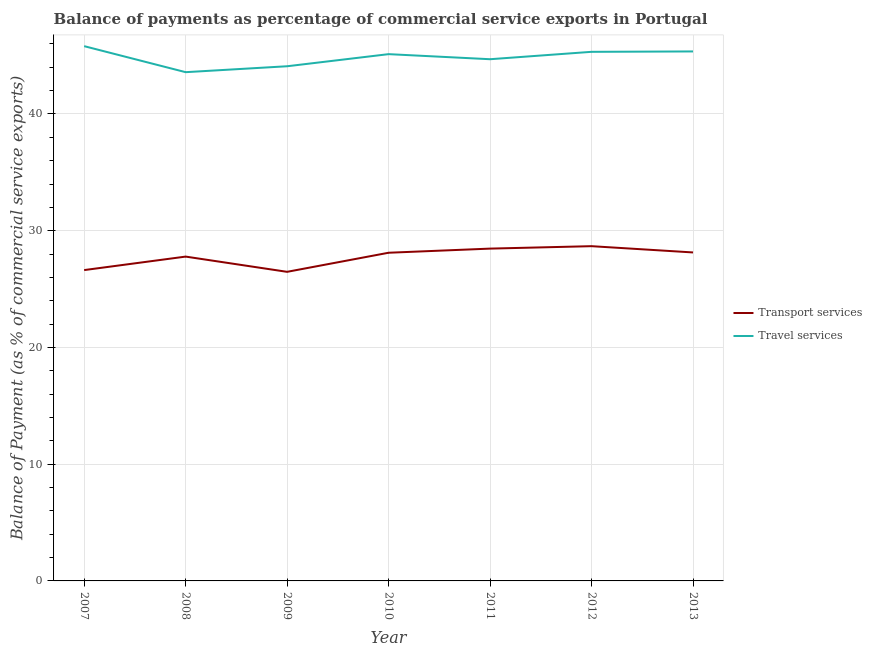How many different coloured lines are there?
Your response must be concise. 2. Does the line corresponding to balance of payments of travel services intersect with the line corresponding to balance of payments of transport services?
Keep it short and to the point. No. Is the number of lines equal to the number of legend labels?
Your answer should be very brief. Yes. What is the balance of payments of travel services in 2009?
Offer a terse response. 44.09. Across all years, what is the maximum balance of payments of transport services?
Make the answer very short. 28.68. Across all years, what is the minimum balance of payments of transport services?
Ensure brevity in your answer.  26.48. In which year was the balance of payments of travel services minimum?
Your response must be concise. 2008. What is the total balance of payments of transport services in the graph?
Provide a short and direct response. 194.28. What is the difference between the balance of payments of transport services in 2010 and that in 2012?
Provide a succinct answer. -0.56. What is the difference between the balance of payments of travel services in 2013 and the balance of payments of transport services in 2010?
Provide a short and direct response. 17.25. What is the average balance of payments of travel services per year?
Provide a short and direct response. 44.85. In the year 2007, what is the difference between the balance of payments of transport services and balance of payments of travel services?
Keep it short and to the point. -19.18. What is the ratio of the balance of payments of travel services in 2007 to that in 2012?
Give a very brief answer. 1.01. Is the difference between the balance of payments of transport services in 2008 and 2010 greater than the difference between the balance of payments of travel services in 2008 and 2010?
Keep it short and to the point. Yes. What is the difference between the highest and the second highest balance of payments of transport services?
Provide a succinct answer. 0.21. What is the difference between the highest and the lowest balance of payments of travel services?
Your answer should be very brief. 2.23. Is the sum of the balance of payments of travel services in 2011 and 2012 greater than the maximum balance of payments of transport services across all years?
Provide a short and direct response. Yes. Is the balance of payments of transport services strictly greater than the balance of payments of travel services over the years?
Your answer should be very brief. No. How many legend labels are there?
Your answer should be very brief. 2. What is the title of the graph?
Make the answer very short. Balance of payments as percentage of commercial service exports in Portugal. What is the label or title of the Y-axis?
Your answer should be very brief. Balance of Payment (as % of commercial service exports). What is the Balance of Payment (as % of commercial service exports) of Transport services in 2007?
Offer a terse response. 26.63. What is the Balance of Payment (as % of commercial service exports) of Travel services in 2007?
Provide a short and direct response. 45.81. What is the Balance of Payment (as % of commercial service exports) of Transport services in 2008?
Ensure brevity in your answer.  27.78. What is the Balance of Payment (as % of commercial service exports) in Travel services in 2008?
Your answer should be very brief. 43.58. What is the Balance of Payment (as % of commercial service exports) of Transport services in 2009?
Your response must be concise. 26.48. What is the Balance of Payment (as % of commercial service exports) of Travel services in 2009?
Your answer should be very brief. 44.09. What is the Balance of Payment (as % of commercial service exports) of Transport services in 2010?
Offer a terse response. 28.11. What is the Balance of Payment (as % of commercial service exports) in Travel services in 2010?
Provide a succinct answer. 45.13. What is the Balance of Payment (as % of commercial service exports) in Transport services in 2011?
Make the answer very short. 28.47. What is the Balance of Payment (as % of commercial service exports) of Travel services in 2011?
Your response must be concise. 44.69. What is the Balance of Payment (as % of commercial service exports) of Transport services in 2012?
Your answer should be compact. 28.68. What is the Balance of Payment (as % of commercial service exports) of Travel services in 2012?
Your answer should be very brief. 45.33. What is the Balance of Payment (as % of commercial service exports) in Transport services in 2013?
Offer a terse response. 28.14. What is the Balance of Payment (as % of commercial service exports) of Travel services in 2013?
Ensure brevity in your answer.  45.36. Across all years, what is the maximum Balance of Payment (as % of commercial service exports) in Transport services?
Your response must be concise. 28.68. Across all years, what is the maximum Balance of Payment (as % of commercial service exports) of Travel services?
Your answer should be compact. 45.81. Across all years, what is the minimum Balance of Payment (as % of commercial service exports) of Transport services?
Your answer should be very brief. 26.48. Across all years, what is the minimum Balance of Payment (as % of commercial service exports) in Travel services?
Make the answer very short. 43.58. What is the total Balance of Payment (as % of commercial service exports) in Transport services in the graph?
Provide a succinct answer. 194.28. What is the total Balance of Payment (as % of commercial service exports) in Travel services in the graph?
Your answer should be very brief. 313.98. What is the difference between the Balance of Payment (as % of commercial service exports) of Transport services in 2007 and that in 2008?
Your answer should be very brief. -1.16. What is the difference between the Balance of Payment (as % of commercial service exports) in Travel services in 2007 and that in 2008?
Give a very brief answer. 2.23. What is the difference between the Balance of Payment (as % of commercial service exports) in Transport services in 2007 and that in 2009?
Ensure brevity in your answer.  0.15. What is the difference between the Balance of Payment (as % of commercial service exports) in Travel services in 2007 and that in 2009?
Your answer should be compact. 1.72. What is the difference between the Balance of Payment (as % of commercial service exports) in Transport services in 2007 and that in 2010?
Offer a terse response. -1.49. What is the difference between the Balance of Payment (as % of commercial service exports) in Travel services in 2007 and that in 2010?
Provide a succinct answer. 0.68. What is the difference between the Balance of Payment (as % of commercial service exports) of Transport services in 2007 and that in 2011?
Your answer should be compact. -1.84. What is the difference between the Balance of Payment (as % of commercial service exports) in Travel services in 2007 and that in 2011?
Offer a very short reply. 1.12. What is the difference between the Balance of Payment (as % of commercial service exports) of Transport services in 2007 and that in 2012?
Provide a succinct answer. -2.05. What is the difference between the Balance of Payment (as % of commercial service exports) in Travel services in 2007 and that in 2012?
Provide a succinct answer. 0.49. What is the difference between the Balance of Payment (as % of commercial service exports) of Transport services in 2007 and that in 2013?
Your answer should be very brief. -1.51. What is the difference between the Balance of Payment (as % of commercial service exports) of Travel services in 2007 and that in 2013?
Give a very brief answer. 0.45. What is the difference between the Balance of Payment (as % of commercial service exports) in Transport services in 2008 and that in 2009?
Ensure brevity in your answer.  1.31. What is the difference between the Balance of Payment (as % of commercial service exports) of Travel services in 2008 and that in 2009?
Your answer should be compact. -0.51. What is the difference between the Balance of Payment (as % of commercial service exports) of Transport services in 2008 and that in 2010?
Make the answer very short. -0.33. What is the difference between the Balance of Payment (as % of commercial service exports) in Travel services in 2008 and that in 2010?
Provide a short and direct response. -1.54. What is the difference between the Balance of Payment (as % of commercial service exports) of Transport services in 2008 and that in 2011?
Your response must be concise. -0.68. What is the difference between the Balance of Payment (as % of commercial service exports) of Travel services in 2008 and that in 2011?
Ensure brevity in your answer.  -1.11. What is the difference between the Balance of Payment (as % of commercial service exports) in Transport services in 2008 and that in 2012?
Your response must be concise. -0.89. What is the difference between the Balance of Payment (as % of commercial service exports) in Travel services in 2008 and that in 2012?
Make the answer very short. -1.74. What is the difference between the Balance of Payment (as % of commercial service exports) of Transport services in 2008 and that in 2013?
Your answer should be compact. -0.36. What is the difference between the Balance of Payment (as % of commercial service exports) of Travel services in 2008 and that in 2013?
Keep it short and to the point. -1.78. What is the difference between the Balance of Payment (as % of commercial service exports) of Transport services in 2009 and that in 2010?
Offer a very short reply. -1.64. What is the difference between the Balance of Payment (as % of commercial service exports) of Travel services in 2009 and that in 2010?
Your answer should be very brief. -1.04. What is the difference between the Balance of Payment (as % of commercial service exports) in Transport services in 2009 and that in 2011?
Offer a very short reply. -1.99. What is the difference between the Balance of Payment (as % of commercial service exports) of Travel services in 2009 and that in 2011?
Offer a terse response. -0.6. What is the difference between the Balance of Payment (as % of commercial service exports) in Transport services in 2009 and that in 2012?
Provide a short and direct response. -2.2. What is the difference between the Balance of Payment (as % of commercial service exports) in Travel services in 2009 and that in 2012?
Provide a short and direct response. -1.24. What is the difference between the Balance of Payment (as % of commercial service exports) of Transport services in 2009 and that in 2013?
Make the answer very short. -1.66. What is the difference between the Balance of Payment (as % of commercial service exports) of Travel services in 2009 and that in 2013?
Ensure brevity in your answer.  -1.27. What is the difference between the Balance of Payment (as % of commercial service exports) of Transport services in 2010 and that in 2011?
Your answer should be compact. -0.35. What is the difference between the Balance of Payment (as % of commercial service exports) of Travel services in 2010 and that in 2011?
Your answer should be very brief. 0.43. What is the difference between the Balance of Payment (as % of commercial service exports) of Transport services in 2010 and that in 2012?
Provide a short and direct response. -0.56. What is the difference between the Balance of Payment (as % of commercial service exports) of Travel services in 2010 and that in 2012?
Provide a short and direct response. -0.2. What is the difference between the Balance of Payment (as % of commercial service exports) in Transport services in 2010 and that in 2013?
Offer a very short reply. -0.03. What is the difference between the Balance of Payment (as % of commercial service exports) of Travel services in 2010 and that in 2013?
Offer a very short reply. -0.23. What is the difference between the Balance of Payment (as % of commercial service exports) of Transport services in 2011 and that in 2012?
Give a very brief answer. -0.21. What is the difference between the Balance of Payment (as % of commercial service exports) of Travel services in 2011 and that in 2012?
Offer a very short reply. -0.63. What is the difference between the Balance of Payment (as % of commercial service exports) in Transport services in 2011 and that in 2013?
Your response must be concise. 0.33. What is the difference between the Balance of Payment (as % of commercial service exports) of Travel services in 2011 and that in 2013?
Your response must be concise. -0.67. What is the difference between the Balance of Payment (as % of commercial service exports) of Transport services in 2012 and that in 2013?
Give a very brief answer. 0.54. What is the difference between the Balance of Payment (as % of commercial service exports) in Travel services in 2012 and that in 2013?
Offer a very short reply. -0.03. What is the difference between the Balance of Payment (as % of commercial service exports) in Transport services in 2007 and the Balance of Payment (as % of commercial service exports) in Travel services in 2008?
Your answer should be very brief. -16.95. What is the difference between the Balance of Payment (as % of commercial service exports) of Transport services in 2007 and the Balance of Payment (as % of commercial service exports) of Travel services in 2009?
Provide a succinct answer. -17.46. What is the difference between the Balance of Payment (as % of commercial service exports) in Transport services in 2007 and the Balance of Payment (as % of commercial service exports) in Travel services in 2010?
Provide a succinct answer. -18.5. What is the difference between the Balance of Payment (as % of commercial service exports) in Transport services in 2007 and the Balance of Payment (as % of commercial service exports) in Travel services in 2011?
Your answer should be very brief. -18.06. What is the difference between the Balance of Payment (as % of commercial service exports) of Transport services in 2007 and the Balance of Payment (as % of commercial service exports) of Travel services in 2012?
Give a very brief answer. -18.7. What is the difference between the Balance of Payment (as % of commercial service exports) of Transport services in 2007 and the Balance of Payment (as % of commercial service exports) of Travel services in 2013?
Give a very brief answer. -18.73. What is the difference between the Balance of Payment (as % of commercial service exports) of Transport services in 2008 and the Balance of Payment (as % of commercial service exports) of Travel services in 2009?
Give a very brief answer. -16.31. What is the difference between the Balance of Payment (as % of commercial service exports) in Transport services in 2008 and the Balance of Payment (as % of commercial service exports) in Travel services in 2010?
Your response must be concise. -17.34. What is the difference between the Balance of Payment (as % of commercial service exports) of Transport services in 2008 and the Balance of Payment (as % of commercial service exports) of Travel services in 2011?
Your response must be concise. -16.91. What is the difference between the Balance of Payment (as % of commercial service exports) in Transport services in 2008 and the Balance of Payment (as % of commercial service exports) in Travel services in 2012?
Provide a short and direct response. -17.54. What is the difference between the Balance of Payment (as % of commercial service exports) in Transport services in 2008 and the Balance of Payment (as % of commercial service exports) in Travel services in 2013?
Keep it short and to the point. -17.58. What is the difference between the Balance of Payment (as % of commercial service exports) in Transport services in 2009 and the Balance of Payment (as % of commercial service exports) in Travel services in 2010?
Ensure brevity in your answer.  -18.65. What is the difference between the Balance of Payment (as % of commercial service exports) in Transport services in 2009 and the Balance of Payment (as % of commercial service exports) in Travel services in 2011?
Your answer should be very brief. -18.21. What is the difference between the Balance of Payment (as % of commercial service exports) of Transport services in 2009 and the Balance of Payment (as % of commercial service exports) of Travel services in 2012?
Your response must be concise. -18.85. What is the difference between the Balance of Payment (as % of commercial service exports) of Transport services in 2009 and the Balance of Payment (as % of commercial service exports) of Travel services in 2013?
Your answer should be compact. -18.88. What is the difference between the Balance of Payment (as % of commercial service exports) in Transport services in 2010 and the Balance of Payment (as % of commercial service exports) in Travel services in 2011?
Provide a succinct answer. -16.58. What is the difference between the Balance of Payment (as % of commercial service exports) in Transport services in 2010 and the Balance of Payment (as % of commercial service exports) in Travel services in 2012?
Your response must be concise. -17.21. What is the difference between the Balance of Payment (as % of commercial service exports) in Transport services in 2010 and the Balance of Payment (as % of commercial service exports) in Travel services in 2013?
Your answer should be compact. -17.25. What is the difference between the Balance of Payment (as % of commercial service exports) in Transport services in 2011 and the Balance of Payment (as % of commercial service exports) in Travel services in 2012?
Give a very brief answer. -16.86. What is the difference between the Balance of Payment (as % of commercial service exports) in Transport services in 2011 and the Balance of Payment (as % of commercial service exports) in Travel services in 2013?
Provide a succinct answer. -16.89. What is the difference between the Balance of Payment (as % of commercial service exports) in Transport services in 2012 and the Balance of Payment (as % of commercial service exports) in Travel services in 2013?
Make the answer very short. -16.68. What is the average Balance of Payment (as % of commercial service exports) of Transport services per year?
Offer a very short reply. 27.75. What is the average Balance of Payment (as % of commercial service exports) in Travel services per year?
Make the answer very short. 44.85. In the year 2007, what is the difference between the Balance of Payment (as % of commercial service exports) of Transport services and Balance of Payment (as % of commercial service exports) of Travel services?
Give a very brief answer. -19.18. In the year 2008, what is the difference between the Balance of Payment (as % of commercial service exports) in Transport services and Balance of Payment (as % of commercial service exports) in Travel services?
Your answer should be very brief. -15.8. In the year 2009, what is the difference between the Balance of Payment (as % of commercial service exports) of Transport services and Balance of Payment (as % of commercial service exports) of Travel services?
Your answer should be very brief. -17.61. In the year 2010, what is the difference between the Balance of Payment (as % of commercial service exports) of Transport services and Balance of Payment (as % of commercial service exports) of Travel services?
Your answer should be compact. -17.01. In the year 2011, what is the difference between the Balance of Payment (as % of commercial service exports) of Transport services and Balance of Payment (as % of commercial service exports) of Travel services?
Offer a terse response. -16.22. In the year 2012, what is the difference between the Balance of Payment (as % of commercial service exports) in Transport services and Balance of Payment (as % of commercial service exports) in Travel services?
Offer a terse response. -16.65. In the year 2013, what is the difference between the Balance of Payment (as % of commercial service exports) in Transport services and Balance of Payment (as % of commercial service exports) in Travel services?
Your response must be concise. -17.22. What is the ratio of the Balance of Payment (as % of commercial service exports) of Transport services in 2007 to that in 2008?
Your answer should be very brief. 0.96. What is the ratio of the Balance of Payment (as % of commercial service exports) of Travel services in 2007 to that in 2008?
Give a very brief answer. 1.05. What is the ratio of the Balance of Payment (as % of commercial service exports) of Transport services in 2007 to that in 2009?
Offer a very short reply. 1.01. What is the ratio of the Balance of Payment (as % of commercial service exports) in Travel services in 2007 to that in 2009?
Your answer should be very brief. 1.04. What is the ratio of the Balance of Payment (as % of commercial service exports) in Transport services in 2007 to that in 2010?
Provide a succinct answer. 0.95. What is the ratio of the Balance of Payment (as % of commercial service exports) of Travel services in 2007 to that in 2010?
Your response must be concise. 1.02. What is the ratio of the Balance of Payment (as % of commercial service exports) in Transport services in 2007 to that in 2011?
Keep it short and to the point. 0.94. What is the ratio of the Balance of Payment (as % of commercial service exports) of Travel services in 2007 to that in 2011?
Give a very brief answer. 1.02. What is the ratio of the Balance of Payment (as % of commercial service exports) in Travel services in 2007 to that in 2012?
Make the answer very short. 1.01. What is the ratio of the Balance of Payment (as % of commercial service exports) in Transport services in 2007 to that in 2013?
Your answer should be compact. 0.95. What is the ratio of the Balance of Payment (as % of commercial service exports) of Transport services in 2008 to that in 2009?
Your answer should be very brief. 1.05. What is the ratio of the Balance of Payment (as % of commercial service exports) of Transport services in 2008 to that in 2010?
Provide a short and direct response. 0.99. What is the ratio of the Balance of Payment (as % of commercial service exports) in Travel services in 2008 to that in 2010?
Your answer should be very brief. 0.97. What is the ratio of the Balance of Payment (as % of commercial service exports) of Travel services in 2008 to that in 2011?
Offer a very short reply. 0.98. What is the ratio of the Balance of Payment (as % of commercial service exports) of Transport services in 2008 to that in 2012?
Offer a terse response. 0.97. What is the ratio of the Balance of Payment (as % of commercial service exports) of Travel services in 2008 to that in 2012?
Keep it short and to the point. 0.96. What is the ratio of the Balance of Payment (as % of commercial service exports) of Transport services in 2008 to that in 2013?
Your answer should be very brief. 0.99. What is the ratio of the Balance of Payment (as % of commercial service exports) of Travel services in 2008 to that in 2013?
Your response must be concise. 0.96. What is the ratio of the Balance of Payment (as % of commercial service exports) of Transport services in 2009 to that in 2010?
Ensure brevity in your answer.  0.94. What is the ratio of the Balance of Payment (as % of commercial service exports) in Travel services in 2009 to that in 2010?
Your response must be concise. 0.98. What is the ratio of the Balance of Payment (as % of commercial service exports) in Transport services in 2009 to that in 2011?
Provide a succinct answer. 0.93. What is the ratio of the Balance of Payment (as % of commercial service exports) in Travel services in 2009 to that in 2011?
Your answer should be very brief. 0.99. What is the ratio of the Balance of Payment (as % of commercial service exports) in Transport services in 2009 to that in 2012?
Your answer should be very brief. 0.92. What is the ratio of the Balance of Payment (as % of commercial service exports) of Travel services in 2009 to that in 2012?
Offer a very short reply. 0.97. What is the ratio of the Balance of Payment (as % of commercial service exports) in Transport services in 2009 to that in 2013?
Keep it short and to the point. 0.94. What is the ratio of the Balance of Payment (as % of commercial service exports) of Travel services in 2009 to that in 2013?
Make the answer very short. 0.97. What is the ratio of the Balance of Payment (as % of commercial service exports) of Transport services in 2010 to that in 2011?
Provide a succinct answer. 0.99. What is the ratio of the Balance of Payment (as % of commercial service exports) in Travel services in 2010 to that in 2011?
Your response must be concise. 1.01. What is the ratio of the Balance of Payment (as % of commercial service exports) in Transport services in 2010 to that in 2012?
Your response must be concise. 0.98. What is the ratio of the Balance of Payment (as % of commercial service exports) in Travel services in 2010 to that in 2012?
Provide a succinct answer. 1. What is the ratio of the Balance of Payment (as % of commercial service exports) of Transport services in 2011 to that in 2012?
Offer a terse response. 0.99. What is the ratio of the Balance of Payment (as % of commercial service exports) of Travel services in 2011 to that in 2012?
Ensure brevity in your answer.  0.99. What is the ratio of the Balance of Payment (as % of commercial service exports) of Transport services in 2011 to that in 2013?
Offer a very short reply. 1.01. What is the ratio of the Balance of Payment (as % of commercial service exports) of Travel services in 2011 to that in 2013?
Offer a very short reply. 0.99. What is the ratio of the Balance of Payment (as % of commercial service exports) in Transport services in 2012 to that in 2013?
Offer a very short reply. 1.02. What is the ratio of the Balance of Payment (as % of commercial service exports) in Travel services in 2012 to that in 2013?
Keep it short and to the point. 1. What is the difference between the highest and the second highest Balance of Payment (as % of commercial service exports) in Transport services?
Provide a short and direct response. 0.21. What is the difference between the highest and the second highest Balance of Payment (as % of commercial service exports) in Travel services?
Provide a succinct answer. 0.45. What is the difference between the highest and the lowest Balance of Payment (as % of commercial service exports) in Transport services?
Ensure brevity in your answer.  2.2. What is the difference between the highest and the lowest Balance of Payment (as % of commercial service exports) of Travel services?
Ensure brevity in your answer.  2.23. 